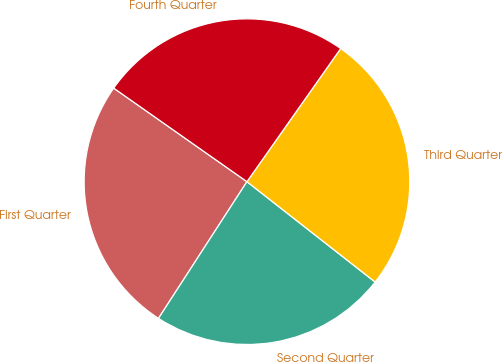Convert chart. <chart><loc_0><loc_0><loc_500><loc_500><pie_chart><fcel>First Quarter<fcel>Second Quarter<fcel>Third Quarter<fcel>Fourth Quarter<nl><fcel>25.6%<fcel>23.57%<fcel>25.81%<fcel>25.02%<nl></chart> 